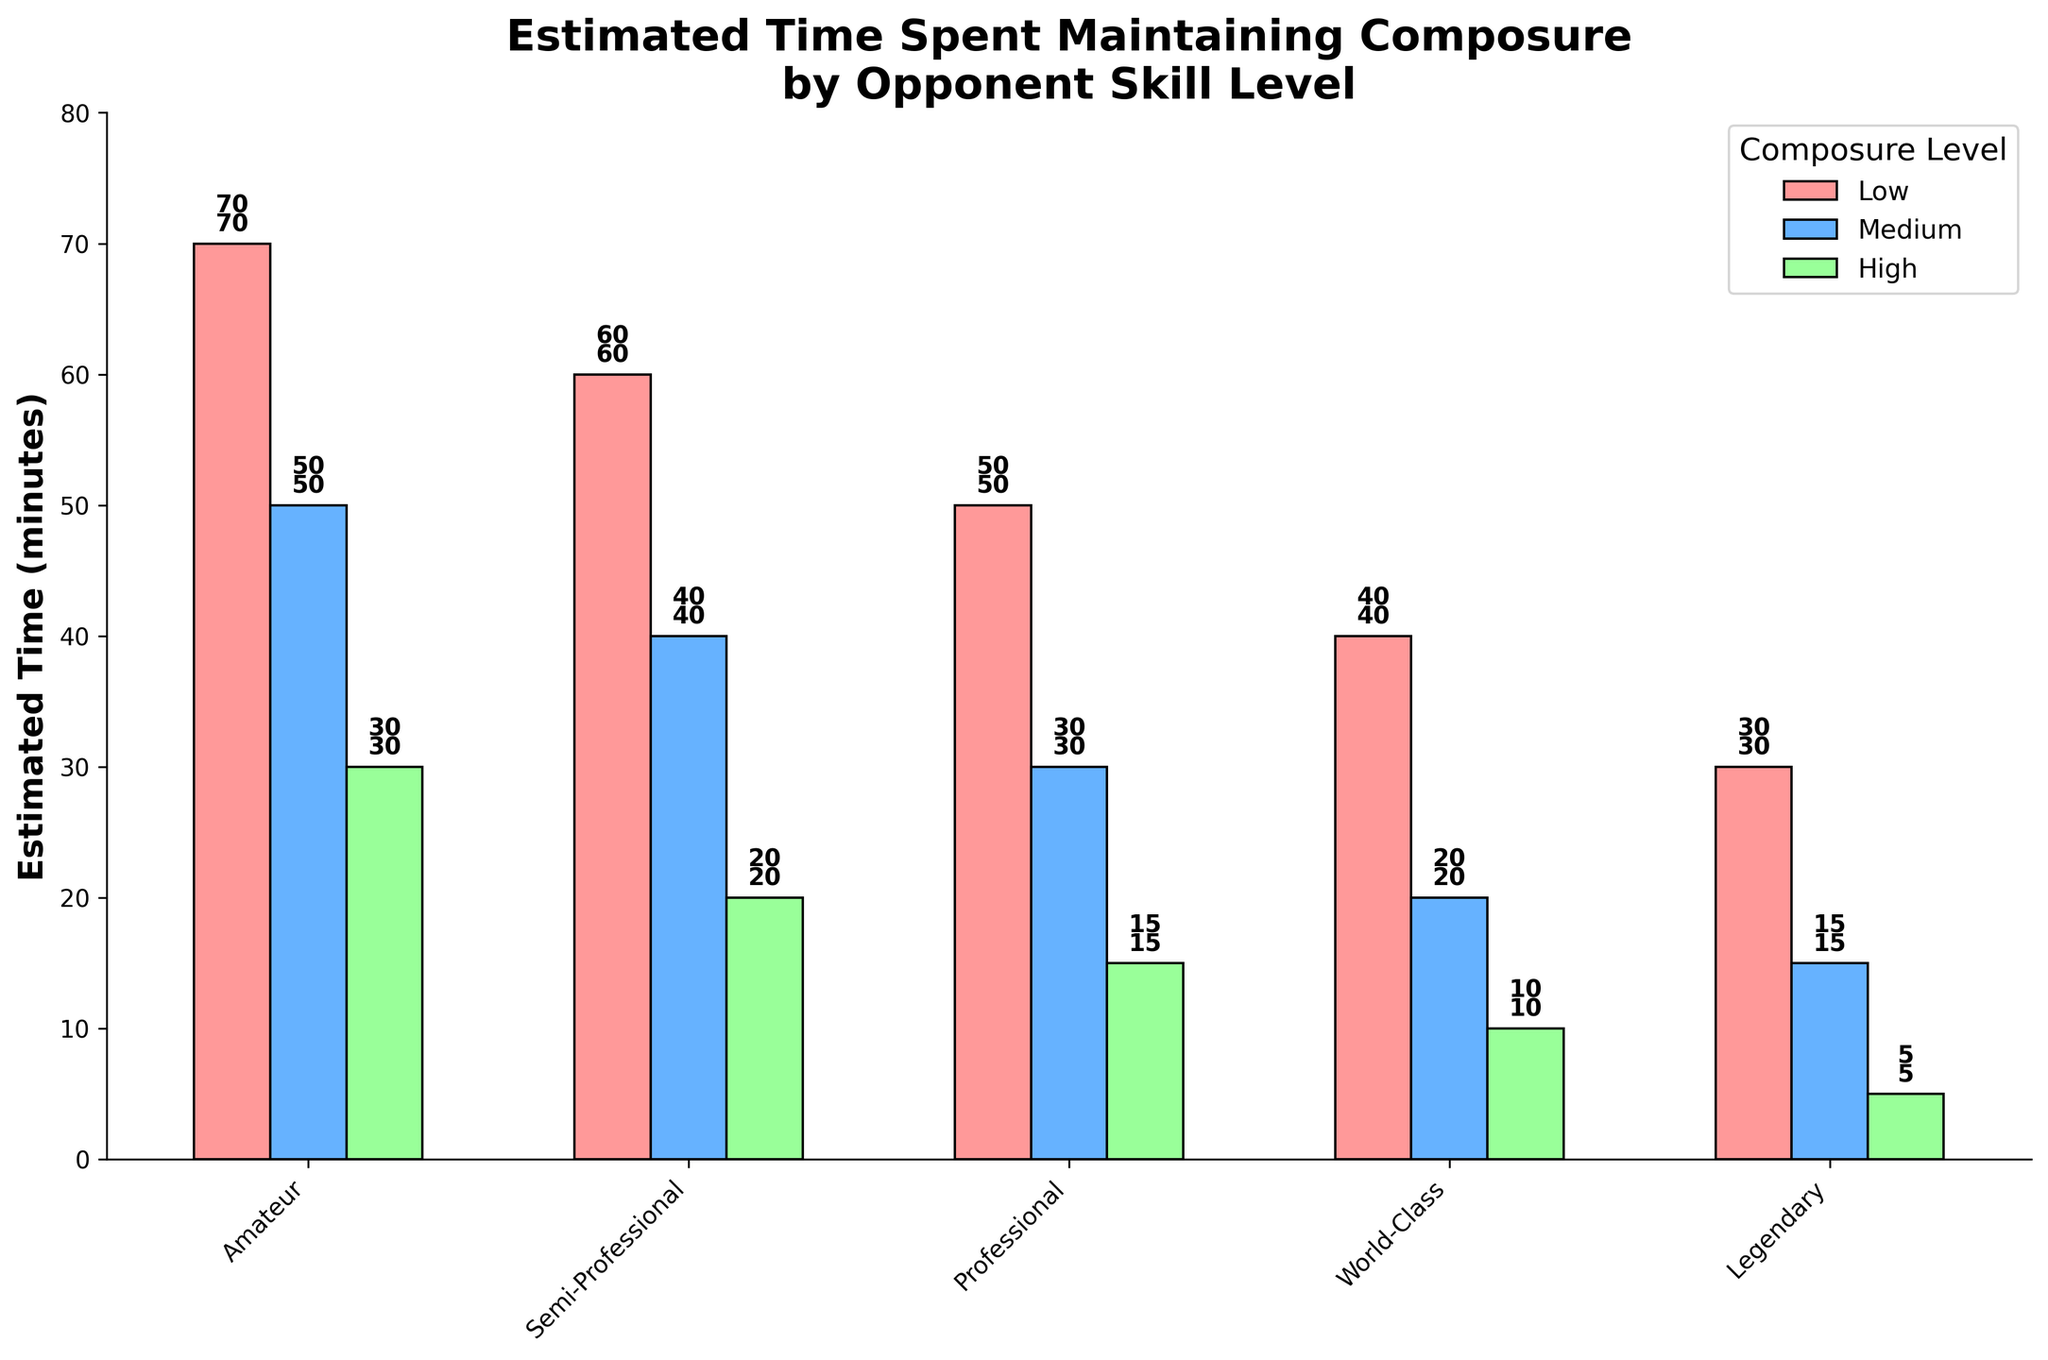What is the title of the chart? The title of the chart is usually placed at the top and is the most prominent text. In this case, it is "Estimated Time Spent Maintaining Composure by Opponent Skill Level".
Answer: Estimated Time Spent Maintaining Composure by Opponent Skill Level Which opponent skill level has the highest estimated time spent maintaining composure for "High" composure level? To find this, look for the tallest green bar (representing "High" composure level) among all skill levels. The "Amateur" category has the highest estimated time at 30 minutes.
Answer: Amateur What is the estimated time spent maintaining composure for "Medium" composure level against Professional opponents? Look at the blue bar (representing "Medium" composure level) for "Professional" opponents on the x-axis. The value on top of the bar shows 30 minutes.
Answer: 30 minutes How many skill levels are displayed in the chart? Count the number of categories on the x-axis. The skill levels listed are "Amateur," "Semi-Professional," "Professional," "World-Class," and "Legendary." This totals to 5 skill levels.
Answer: 5 Which skill level sees the biggest drop in estimated time from "Low" to "High" composure levels? Calculate the difference between "Low" and "High" for each skill level and find the maximum. For "Amateur," the difference is 70 - 30 = 40; "Semi-Professional," 60 - 20 = 40; "Professional," 50 - 15 = 35; "World-Class," 40 - 10 = 30; "Legendary," 30 - 5 = 25. The largest drop is for "Amateur" and "Semi-Professional" at 40 minutes each.
Answer: Amateur and Semi-Professional Which composure level consistently decreases as opponent skill level increases? Examine the trend for each composure level across skill levels. All levels—Low, Medium, and High—decrease as the opponent skill level increases.
Answer: Low, Medium, High Calculate the average estimated time spent maintaining composure for "Semi-Professional" opponents across all composure levels. Add the values for "Semi-Professional" in each composure level and divide by the number of levels: (60 + 40 + 20) / 3 = 120 / 3 = 40 minutes.
Answer: 40 minutes Which opponent skill level shows the least estimated time spent maintaining composure in the "Medium" composure level? Find the smallest blue bar (representing "Medium" composure level) among the skill levels. The "Legendary" category has the smallest estimated time at 15 minutes.
Answer: Legendary 